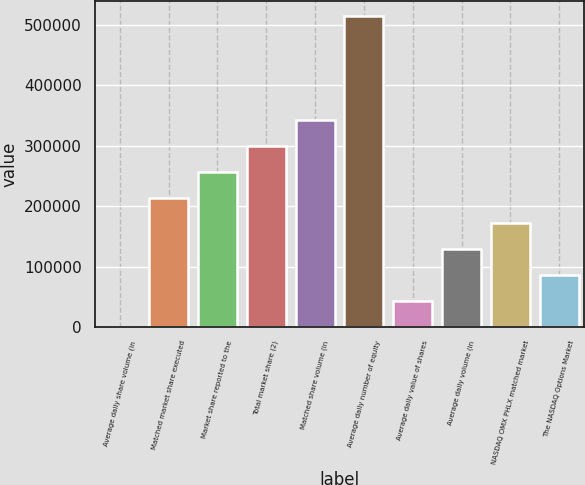<chart> <loc_0><loc_0><loc_500><loc_500><bar_chart><fcel>Average daily share volume (in<fcel>Matched market share executed<fcel>Market share reported to the<fcel>Total market share (2)<fcel>Matched share volume (in<fcel>Average daily number of equity<fcel>Average daily value of shares<fcel>Average daily volume (in<fcel>NASDAQ OMX PHLX matched market<fcel>The NASDAQ Options Market<nl><fcel>2.19<fcel>214263<fcel>257115<fcel>299967<fcel>342819<fcel>514227<fcel>42854.3<fcel>128558<fcel>171411<fcel>85706.4<nl></chart> 